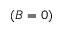Convert formula to latex. <formula><loc_0><loc_0><loc_500><loc_500>( B = 0 )</formula> 